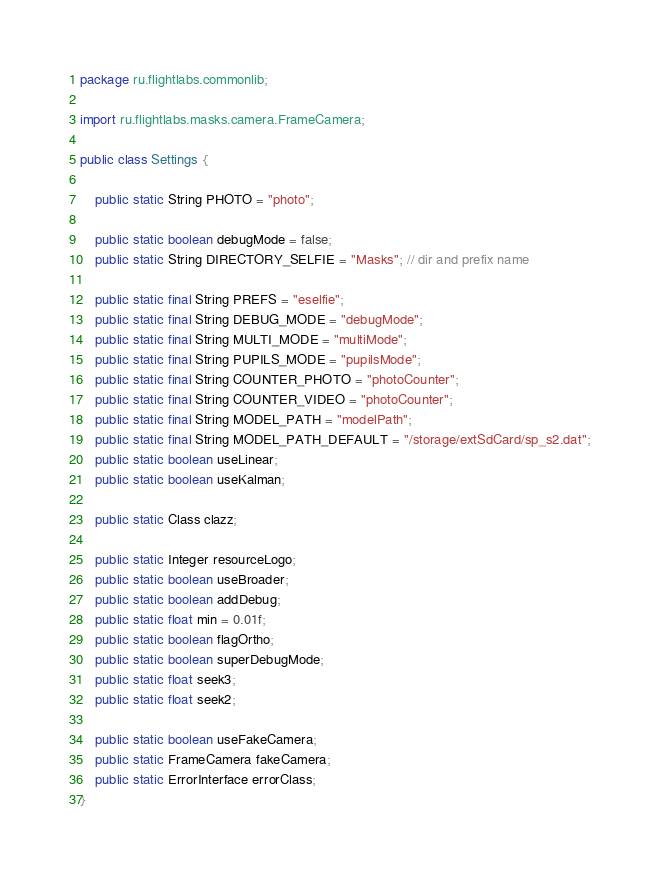Convert code to text. <code><loc_0><loc_0><loc_500><loc_500><_Java_>package ru.flightlabs.commonlib;

import ru.flightlabs.masks.camera.FrameCamera;

public class Settings {

    public static String PHOTO = "photo";

    public static boolean debugMode = false;
    public static String DIRECTORY_SELFIE = "Masks"; // dir and prefix name
    
    public static final String PREFS = "eselfie";
    public static final String DEBUG_MODE = "debugMode";
    public static final String MULTI_MODE = "multiMode";
    public static final String PUPILS_MODE = "pupilsMode";
    public static final String COUNTER_PHOTO = "photoCounter";
    public static final String COUNTER_VIDEO = "photoCounter";
    public static final String MODEL_PATH = "modelPath";
    public static final String MODEL_PATH_DEFAULT = "/storage/extSdCard/sp_s2.dat";
    public static boolean useLinear;
    public static boolean useKalman;

    public static Class clazz;

    public static Integer resourceLogo;
    public static boolean useBroader;
    public static boolean addDebug;
    public static float min = 0.01f;
    public static boolean flagOrtho;
    public static boolean superDebugMode;
    public static float seek3;
    public static float seek2;

    public static boolean useFakeCamera;
    public static FrameCamera fakeCamera;
    public static ErrorInterface errorClass;
}
</code> 